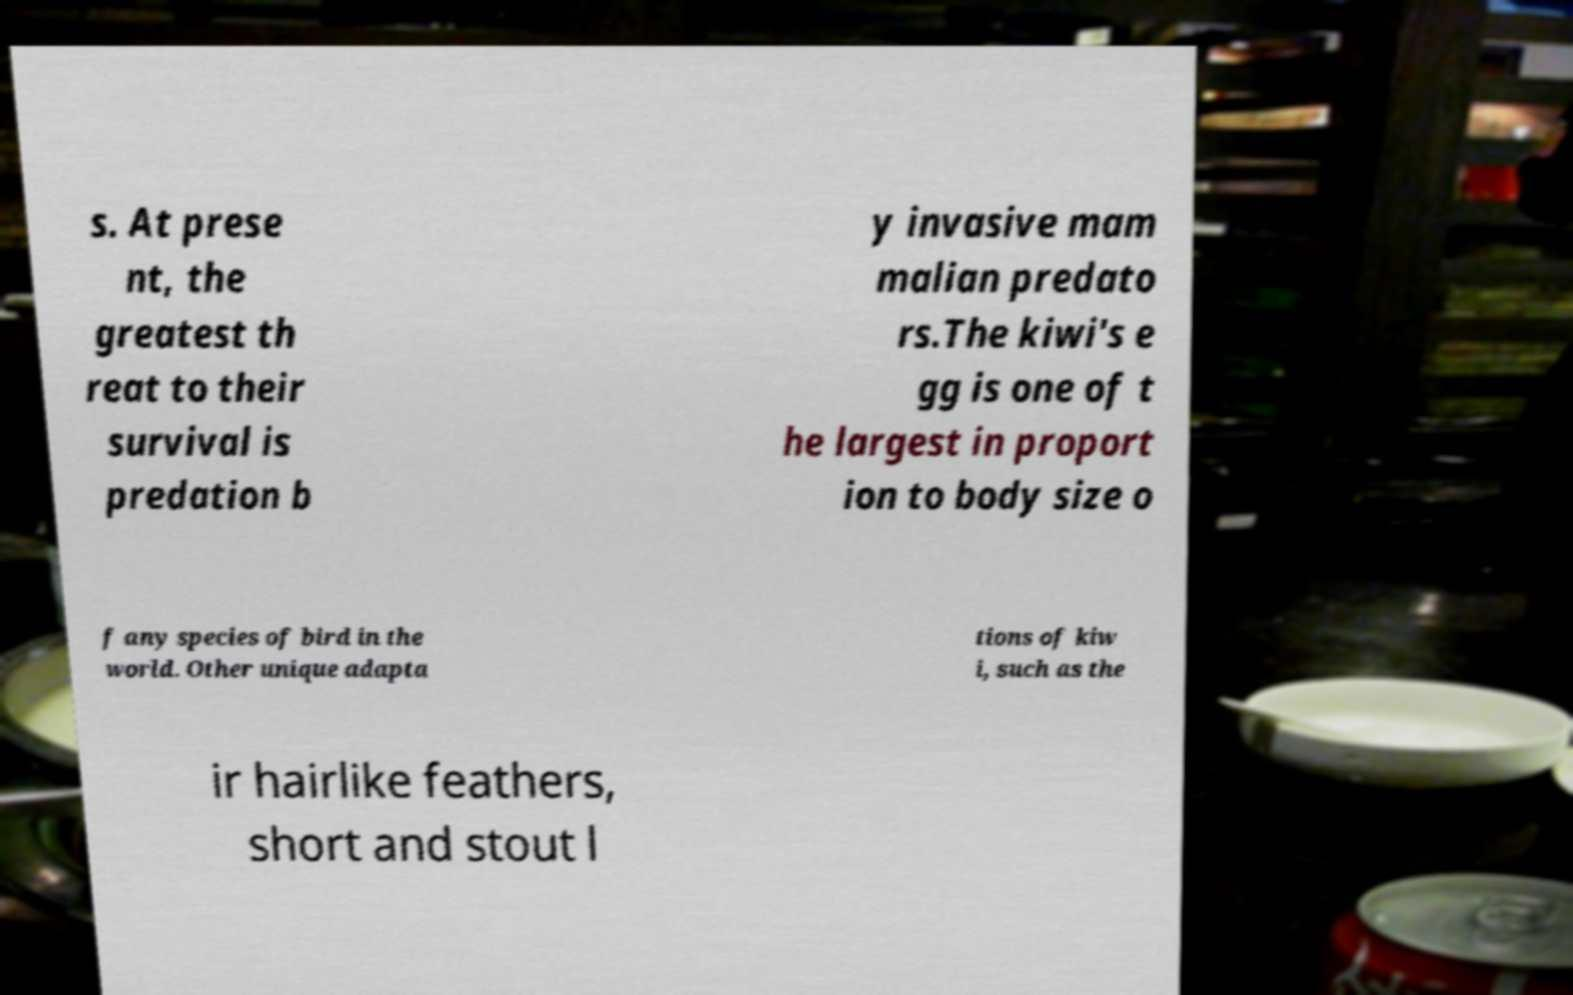Please identify and transcribe the text found in this image. s. At prese nt, the greatest th reat to their survival is predation b y invasive mam malian predato rs.The kiwi's e gg is one of t he largest in proport ion to body size o f any species of bird in the world. Other unique adapta tions of kiw i, such as the ir hairlike feathers, short and stout l 